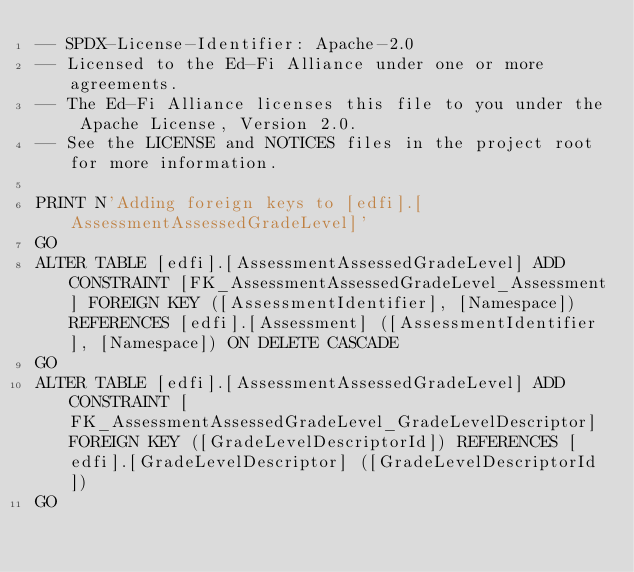Convert code to text. <code><loc_0><loc_0><loc_500><loc_500><_SQL_>-- SPDX-License-Identifier: Apache-2.0
-- Licensed to the Ed-Fi Alliance under one or more agreements.
-- The Ed-Fi Alliance licenses this file to you under the Apache License, Version 2.0.
-- See the LICENSE and NOTICES files in the project root for more information.

PRINT N'Adding foreign keys to [edfi].[AssessmentAssessedGradeLevel]'
GO
ALTER TABLE [edfi].[AssessmentAssessedGradeLevel] ADD CONSTRAINT [FK_AssessmentAssessedGradeLevel_Assessment] FOREIGN KEY ([AssessmentIdentifier], [Namespace]) REFERENCES [edfi].[Assessment] ([AssessmentIdentifier], [Namespace]) ON DELETE CASCADE
GO
ALTER TABLE [edfi].[AssessmentAssessedGradeLevel] ADD CONSTRAINT [FK_AssessmentAssessedGradeLevel_GradeLevelDescriptor] FOREIGN KEY ([GradeLevelDescriptorId]) REFERENCES [edfi].[GradeLevelDescriptor] ([GradeLevelDescriptorId])
GO
</code> 